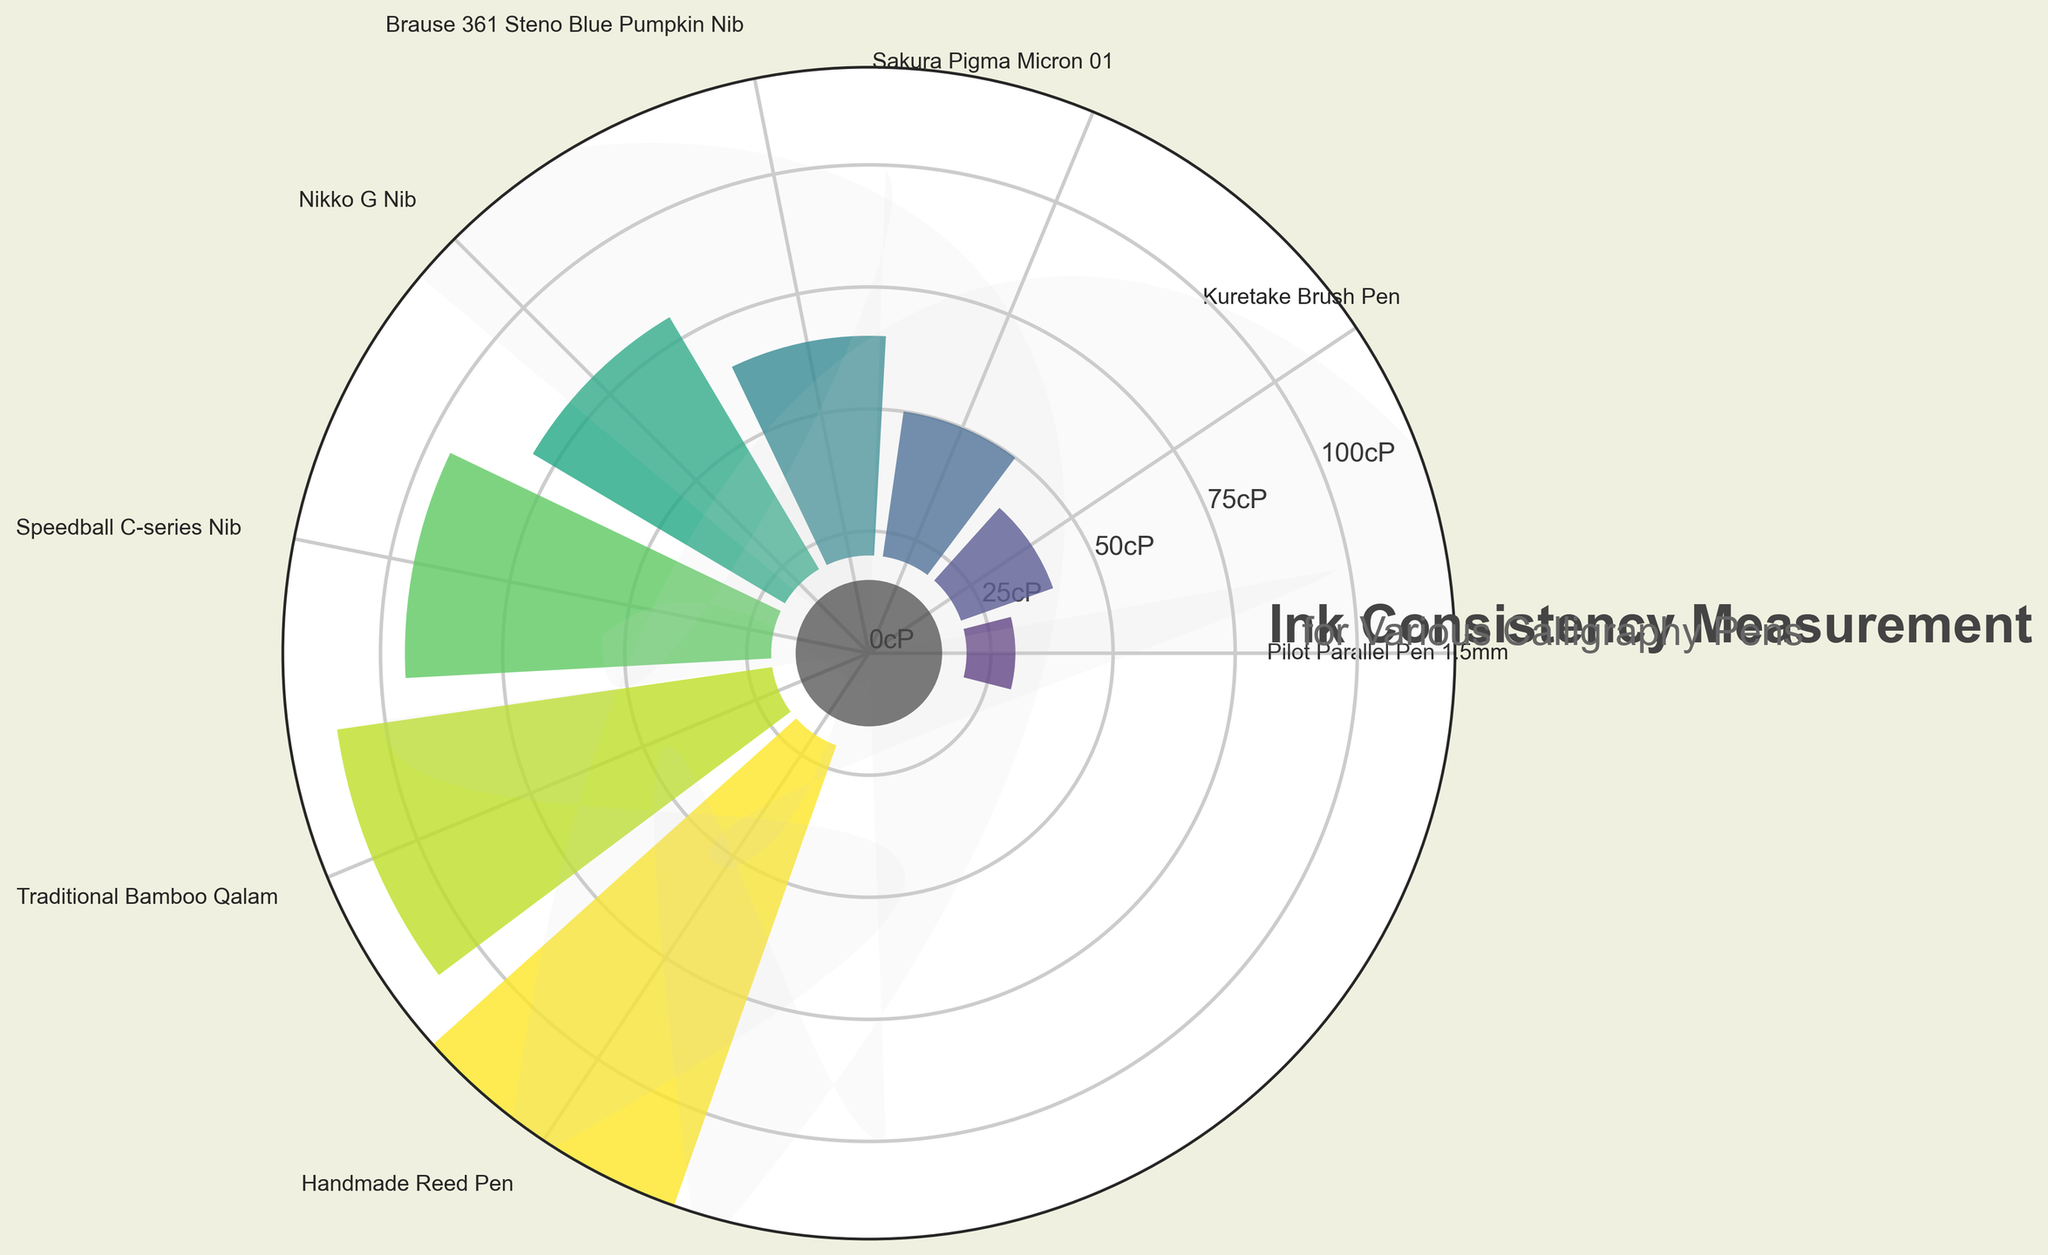Which pen type has the highest ink consistency? The ink consistency for each pen type is plotted on the gauge chart. The pen with the highest value is identified by checking the pen type with the longest bar.
Answer: Handmade Reed Pen Which pen type has the lowest ink consistency? The ink consistency for each pen type is plotted on the gauge chart. The pen with the shortest bar is identified.
Answer: Pilot Parallel Pen 1.5mm What is the ink consistency measured for the Kuretake Brush Pen? Find the Kuretake Brush Pen label on the chart and observe the length of its bar, which correlates to its ink consistency value.
Answer: 20 cP Which pen types have an ink consistency higher than 60 cP? Identify the bars that extend beyond the 60 cP mark and note the corresponding pen types.
Answer: Speedball C-series Nib, Traditional Bamboo Qalam, Handmade Reed Pen What is the difference in ink consistency between the Nikko G Nib and the Sakura Pigma Micron 01 pen? Locate the bars for both pens and subtract the ink consistency of Sakura Pigma Micron 01 (30 cP) from that of Nikko G Nib (60 cP).
Answer: 30 cP Which ink consistency values appear in the chart as labeled y-axis ticks? The y-axis ticks are labeled at regular intervals from the bottom to the top of the gauge. Identify these intervals.
Answer: 0 cP, 25 cP, 50 cP, 75 cP, 100 cP Which pen types are categorized in the middle range (40-70 cP) of ink consistency? Identify the pen types with bars falling between 40 cP and 70 cP marks.
Answer: Brause 361 Steno Blue Pumpkin Nib, Nikko G Nib, Speedball C-series Nib 